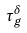<formula> <loc_0><loc_0><loc_500><loc_500>\tau _ { g } ^ { \delta }</formula> 